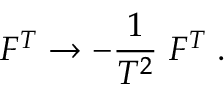Convert formula to latex. <formula><loc_0><loc_0><loc_500><loc_500>F ^ { T } \rightarrow - { \frac { 1 } { T ^ { 2 } } } F ^ { T } \, .</formula> 